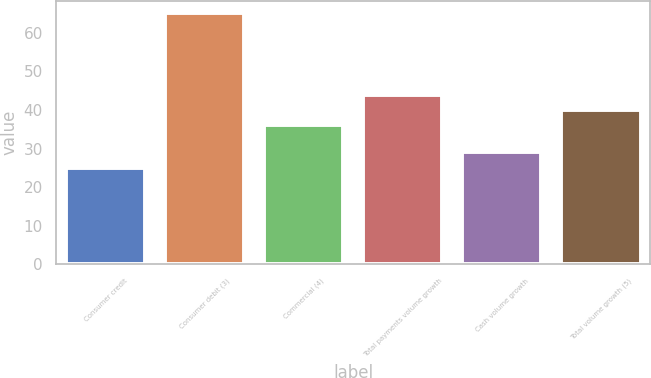Convert chart. <chart><loc_0><loc_0><loc_500><loc_500><bar_chart><fcel>Consumer credit<fcel>Consumer debit (3)<fcel>Commercial (4)<fcel>Total payments volume growth<fcel>Cash volume growth<fcel>Total volume growth (5)<nl><fcel>25<fcel>65<fcel>36<fcel>44<fcel>29<fcel>40<nl></chart> 